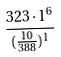Convert formula to latex. <formula><loc_0><loc_0><loc_500><loc_500>\frac { 3 2 3 \cdot 1 ^ { 6 } } { ( \frac { 1 0 } { 3 8 8 } ) ^ { 1 } }</formula> 